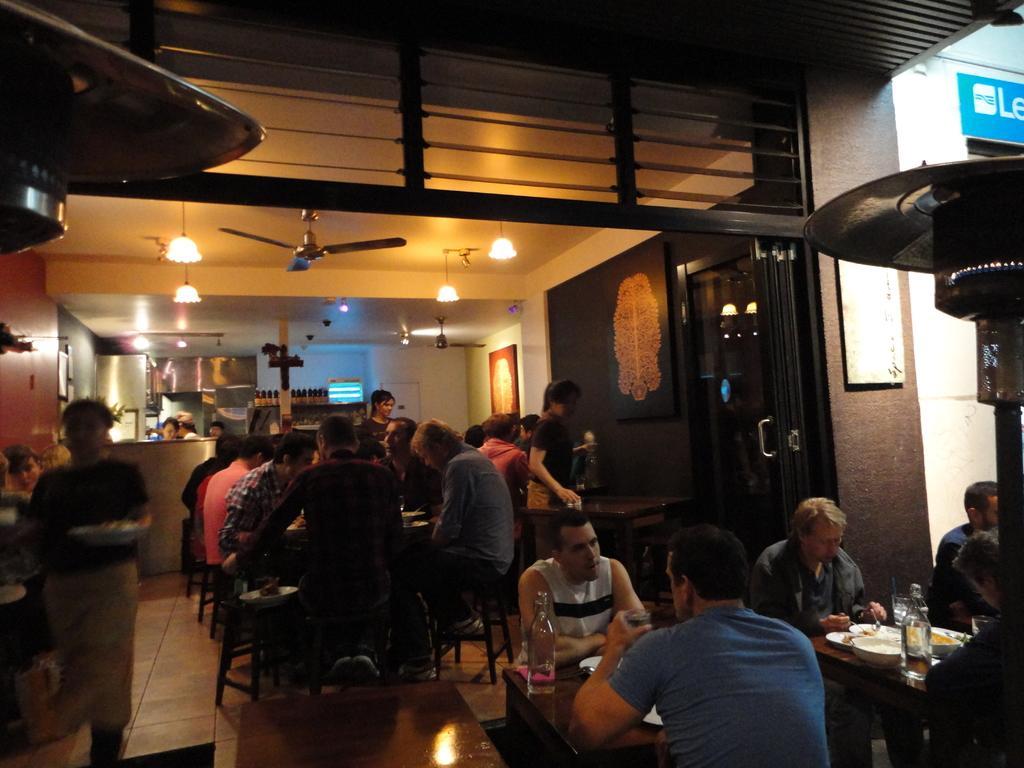Could you give a brief overview of what you see in this image? In this image I can see the group of people sitting on the chairs. And I can see few people are standing. There is a table in-front of these people. On the table I can see the plates with food, bowl, bottle and glass. In the back I can see few more people. These people are wearing the different color dresses. In the back I can see the fan and the lights. 